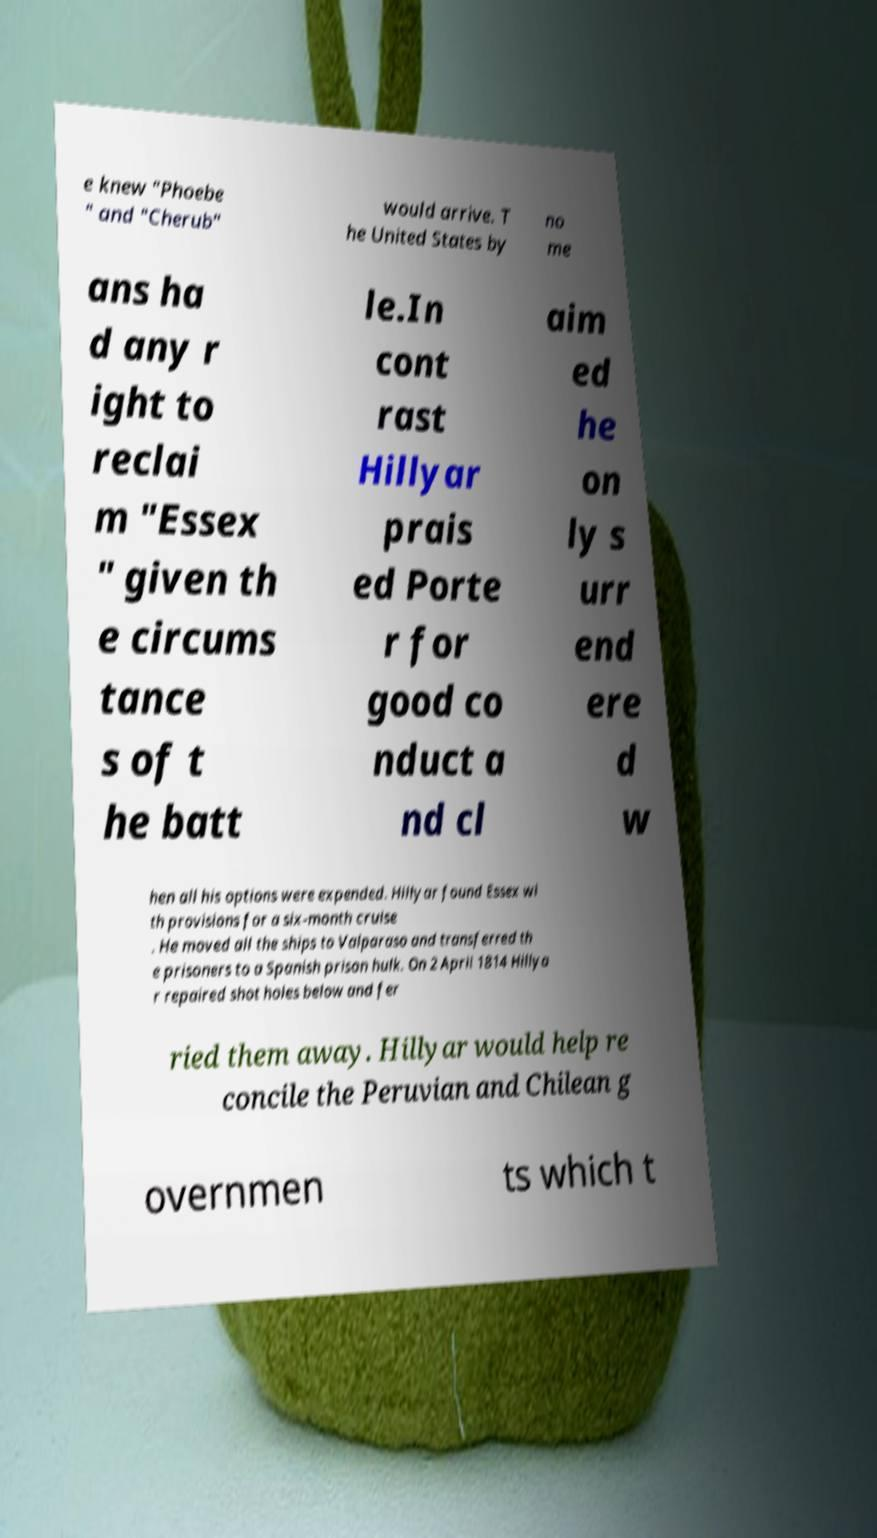For documentation purposes, I need the text within this image transcribed. Could you provide that? e knew "Phoebe " and "Cherub" would arrive. T he United States by no me ans ha d any r ight to reclai m "Essex " given th e circums tance s of t he batt le.In cont rast Hillyar prais ed Porte r for good co nduct a nd cl aim ed he on ly s urr end ere d w hen all his options were expended. Hillyar found Essex wi th provisions for a six-month cruise . He moved all the ships to Valparaso and transferred th e prisoners to a Spanish prison hulk. On 2 April 1814 Hillya r repaired shot holes below and fer ried them away. Hillyar would help re concile the Peruvian and Chilean g overnmen ts which t 